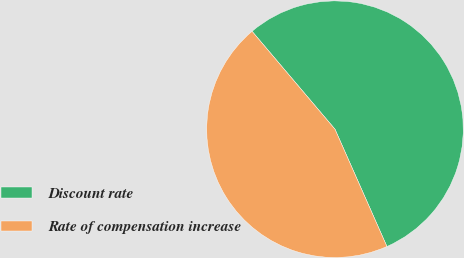<chart> <loc_0><loc_0><loc_500><loc_500><pie_chart><fcel>Discount rate<fcel>Rate of compensation increase<nl><fcel>54.55%<fcel>45.45%<nl></chart> 